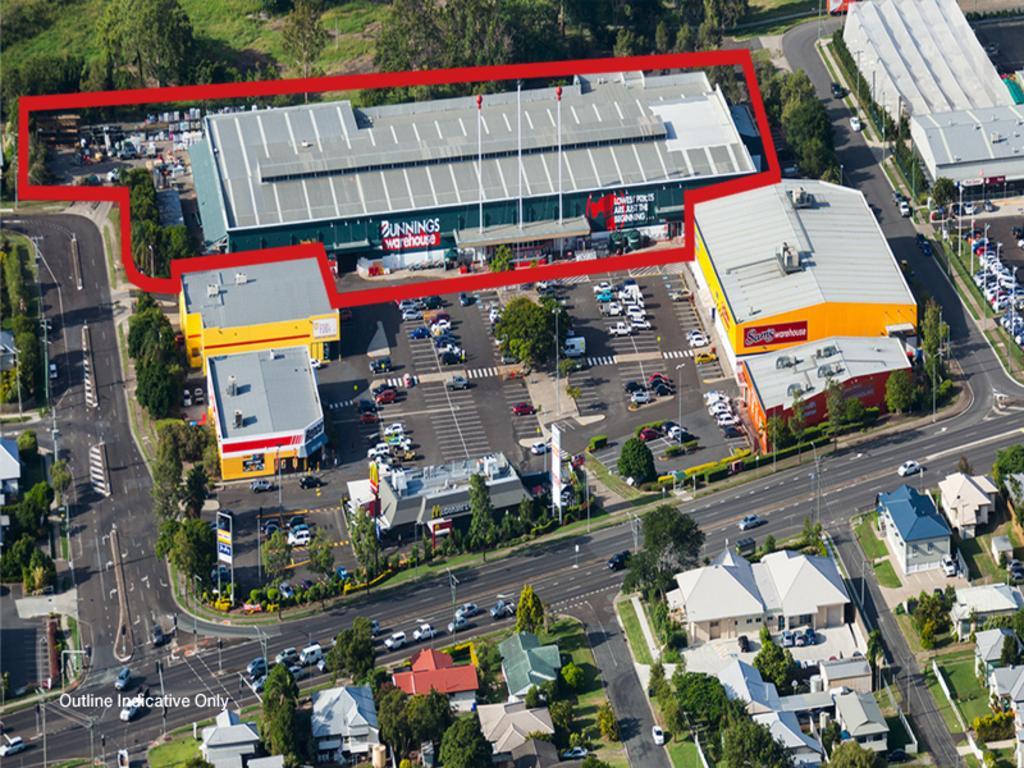How would you summarize this image in a sentence or two? In this image there are cars on the road. There are buildings, trees, hoardings. There are street lights, poles. There is some text on the left side of the image. 